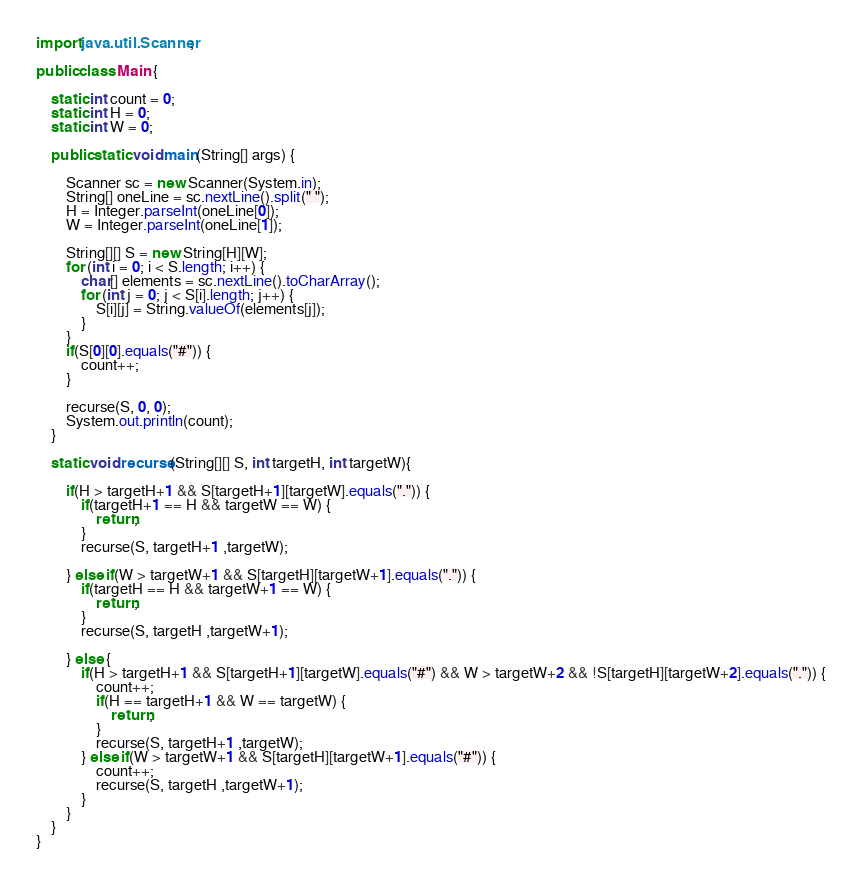Convert code to text. <code><loc_0><loc_0><loc_500><loc_500><_Java_>import java.util.Scanner;

public class Main {

	static int count = 0;
	static int H = 0;
	static int W = 0;

	public static void main(String[] args) {

		Scanner sc = new Scanner(System.in);
		String[] oneLine = sc.nextLine().split(" ");
		H = Integer.parseInt(oneLine[0]);
		W = Integer.parseInt(oneLine[1]);

		String[][] S = new String[H][W];
		for (int i = 0; i < S.length; i++) {
			char[] elements = sc.nextLine().toCharArray();
			for (int j = 0; j < S[i].length; j++) {
				S[i][j] = String.valueOf(elements[j]);
			}
		}
		if(S[0][0].equals("#")) {
			count++;
		}

		recurse(S, 0, 0);
		System.out.println(count);
	}

	static void recurse(String[][] S, int targetH, int targetW){

		if(H > targetH+1 && S[targetH+1][targetW].equals(".")) {
			if(targetH+1 == H && targetW == W) {
				return;
			}
			recurse(S, targetH+1 ,targetW);

		} else if(W > targetW+1 && S[targetH][targetW+1].equals(".")) {
			if(targetH == H && targetW+1 == W) {
				return;
			}
			recurse(S, targetH ,targetW+1);

		} else {
			if(H > targetH+1 && S[targetH+1][targetW].equals("#") && W > targetW+2 && !S[targetH][targetW+2].equals(".")) {
				count++;
				if(H == targetH+1 && W == targetW) {
					return;
				}
				recurse(S, targetH+1 ,targetW);
			} else if(W > targetW+1 && S[targetH][targetW+1].equals("#")) {
				count++;
				recurse(S, targetH ,targetW+1);
			}
		}
	}
}</code> 